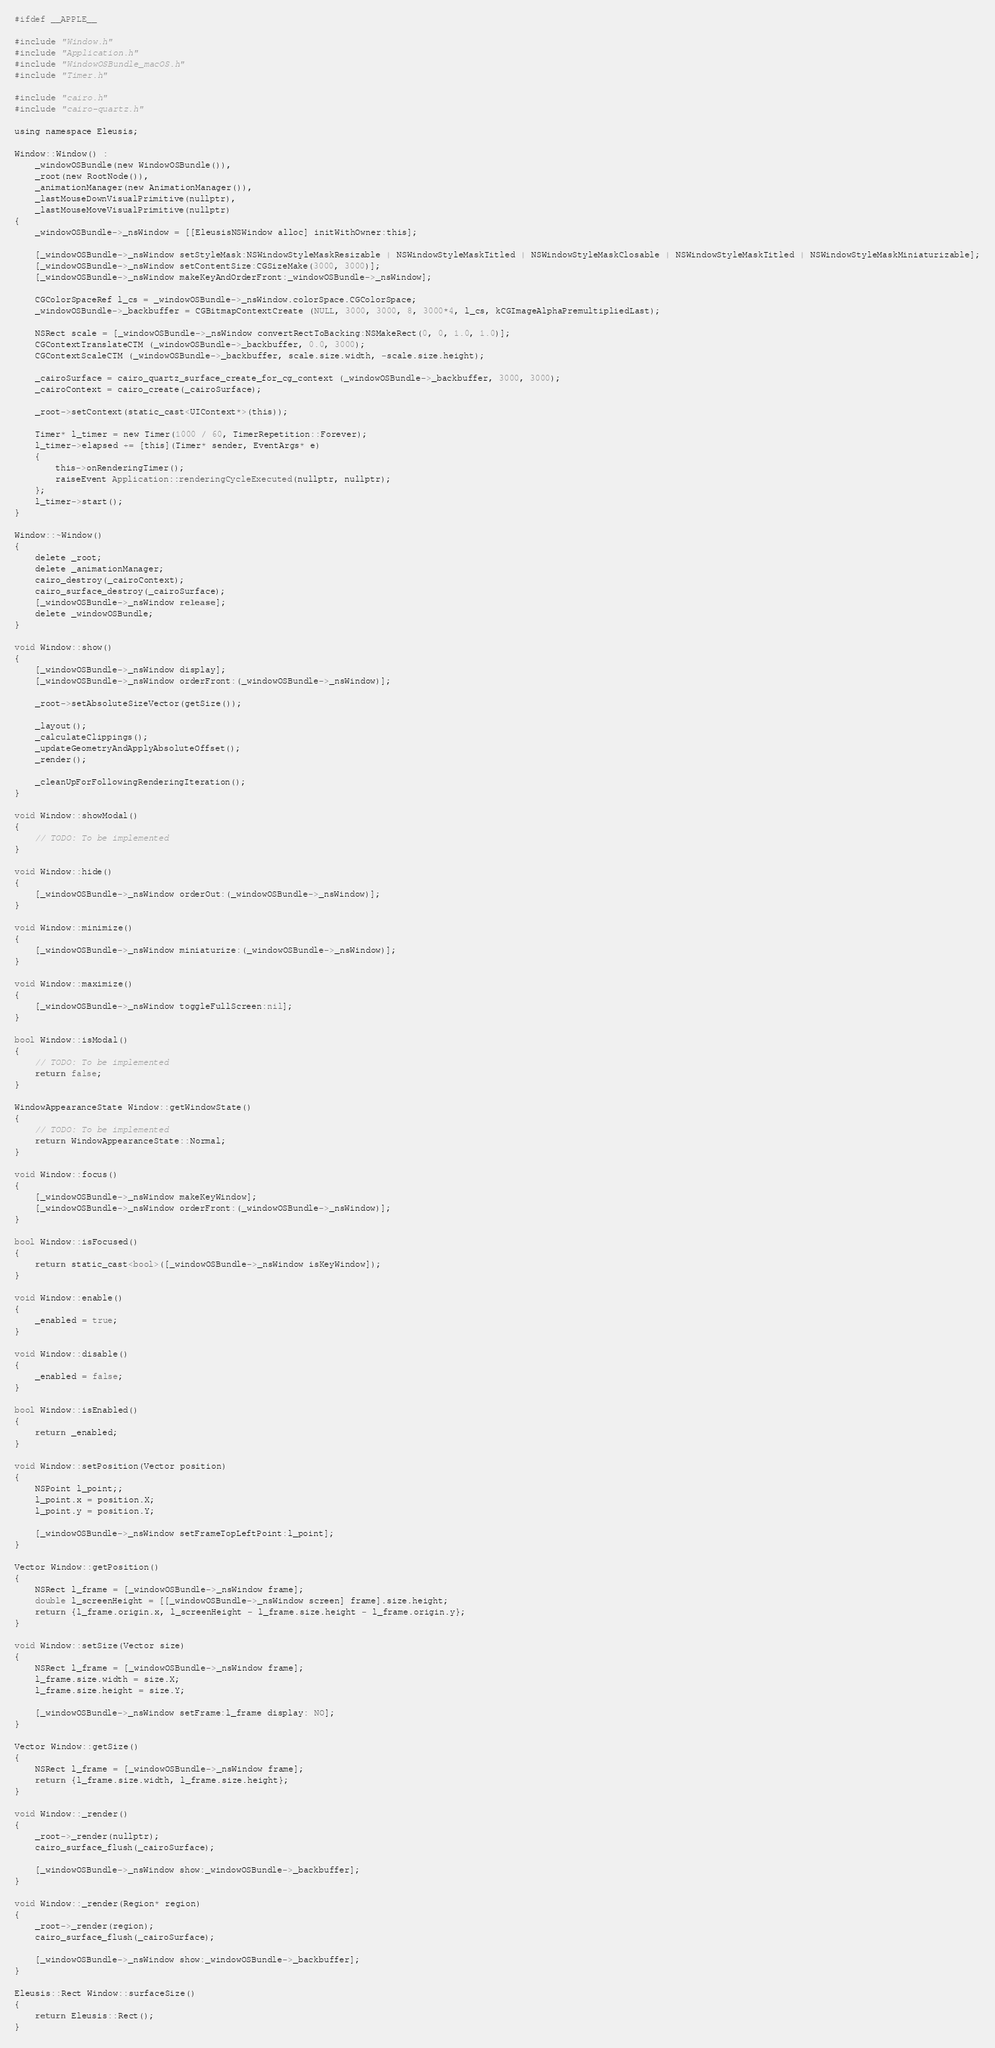Convert code to text. <code><loc_0><loc_0><loc_500><loc_500><_ObjectiveC_>#ifdef __APPLE__

#include "Window.h"
#include "Application.h"
#include "WindowOSBundle_macOS.h"
#include "Timer.h"

#include "cairo.h"
#include "cairo-quartz.h"

using namespace Eleusis;

Window::Window() :
    _windowOSBundle(new WindowOSBundle()),
    _root(new RootNode()),
    _animationManager(new AnimationManager()),
    _lastMouseDownVisualPrimitive(nullptr),
    _lastMouseMoveVisualPrimitive(nullptr)
{
    _windowOSBundle->_nsWindow = [[EleusisNSWindow alloc] initWithOwner:this];
    
    [_windowOSBundle->_nsWindow setStyleMask:NSWindowStyleMaskResizable | NSWindowStyleMaskTitled | NSWindowStyleMaskClosable | NSWindowStyleMaskTitled | NSWindowStyleMaskMiniaturizable];
    [_windowOSBundle->_nsWindow setContentSize:CGSizeMake(3000, 3000)];
    [_windowOSBundle->_nsWindow makeKeyAndOrderFront:_windowOSBundle->_nsWindow];
    
    CGColorSpaceRef l_cs = _windowOSBundle->_nsWindow.colorSpace.CGColorSpace;
    _windowOSBundle->_backbuffer = CGBitmapContextCreate (NULL, 3000, 3000, 8, 3000*4, l_cs, kCGImageAlphaPremultipliedLast);

    NSRect scale = [_windowOSBundle->_nsWindow convertRectToBacking:NSMakeRect(0, 0, 1.0, 1.0)];
    CGContextTranslateCTM (_windowOSBundle->_backbuffer, 0.0, 3000);
    CGContextScaleCTM (_windowOSBundle->_backbuffer, scale.size.width, -scale.size.height);

    _cairoSurface = cairo_quartz_surface_create_for_cg_context (_windowOSBundle->_backbuffer, 3000, 3000);
    _cairoContext = cairo_create(_cairoSurface);

    _root->setContext(static_cast<UIContext*>(this));

    Timer* l_timer = new Timer(1000 / 60, TimerRepetition::Forever);
    l_timer->elapsed += [this](Timer* sender, EventArgs* e)
    {
        this->onRenderingTimer();
        raiseEvent Application::renderingCycleExecuted(nullptr, nullptr);
    };
    l_timer->start();
}

Window::~Window()
{
    delete _root;
    delete _animationManager;
    cairo_destroy(_cairoContext);
    cairo_surface_destroy(_cairoSurface);
    [_windowOSBundle->_nsWindow release];
    delete _windowOSBundle;
}

void Window::show()
{
    [_windowOSBundle->_nsWindow display];
    [_windowOSBundle->_nsWindow orderFront:(_windowOSBundle->_nsWindow)];

    _root->setAbsoluteSizeVector(getSize());

    _layout();
    _calculateClippings();
    _updateGeometryAndApplyAbsoluteOffset();
    _render();

    _cleanUpForFollowingRenderingIteration();
}

void Window::showModal()
{
    // TODO: To be implemented
}

void Window::hide()
{
    [_windowOSBundle->_nsWindow orderOut:(_windowOSBundle->_nsWindow)];
}

void Window::minimize()
{
    [_windowOSBundle->_nsWindow miniaturize:(_windowOSBundle->_nsWindow)];
}

void Window::maximize()
{
    [_windowOSBundle->_nsWindow toggleFullScreen:nil];
}

bool Window::isModal()
{
    // TODO: To be implemented
    return false;
}

WindowAppearanceState Window::getWindowState()
{
    // TODO: To be implemented
    return WindowAppearanceState::Normal;
}

void Window::focus()
{
    [_windowOSBundle->_nsWindow makeKeyWindow];
    [_windowOSBundle->_nsWindow orderFront:(_windowOSBundle->_nsWindow)];
}

bool Window::isFocused()
{
    return static_cast<bool>([_windowOSBundle->_nsWindow isKeyWindow]);
}

void Window::enable()
{
    _enabled = true;
}

void Window::disable()
{
    _enabled = false;
}

bool Window::isEnabled()
{
    return _enabled;
}

void Window::setPosition(Vector position)
{
    NSPoint l_point;;
    l_point.x = position.X;
    l_point.y = position.Y;
    
    [_windowOSBundle->_nsWindow setFrameTopLeftPoint:l_point];
}

Vector Window::getPosition()
{
    NSRect l_frame = [_windowOSBundle->_nsWindow frame];
    double l_screenHeight = [[_windowOSBundle->_nsWindow screen] frame].size.height;
    return {l_frame.origin.x, l_screenHeight - l_frame.size.height - l_frame.origin.y};
}

void Window::setSize(Vector size)
{
    NSRect l_frame = [_windowOSBundle->_nsWindow frame];
    l_frame.size.width = size.X;
    l_frame.size.height = size.Y;
    
    [_windowOSBundle->_nsWindow setFrame:l_frame display: NO];
}

Vector Window::getSize()
{
    NSRect l_frame = [_windowOSBundle->_nsWindow frame];
    return {l_frame.size.width, l_frame.size.height};
}

void Window::_render()
{
    _root->_render(nullptr);
    cairo_surface_flush(_cairoSurface);

    [_windowOSBundle->_nsWindow show:_windowOSBundle->_backbuffer];
}

void Window::_render(Region* region)
{
    _root->_render(region);
    cairo_surface_flush(_cairoSurface);

    [_windowOSBundle->_nsWindow show:_windowOSBundle->_backbuffer];
}

Eleusis::Rect Window::surfaceSize()
{
    return Eleusis::Rect();
}
</code> 